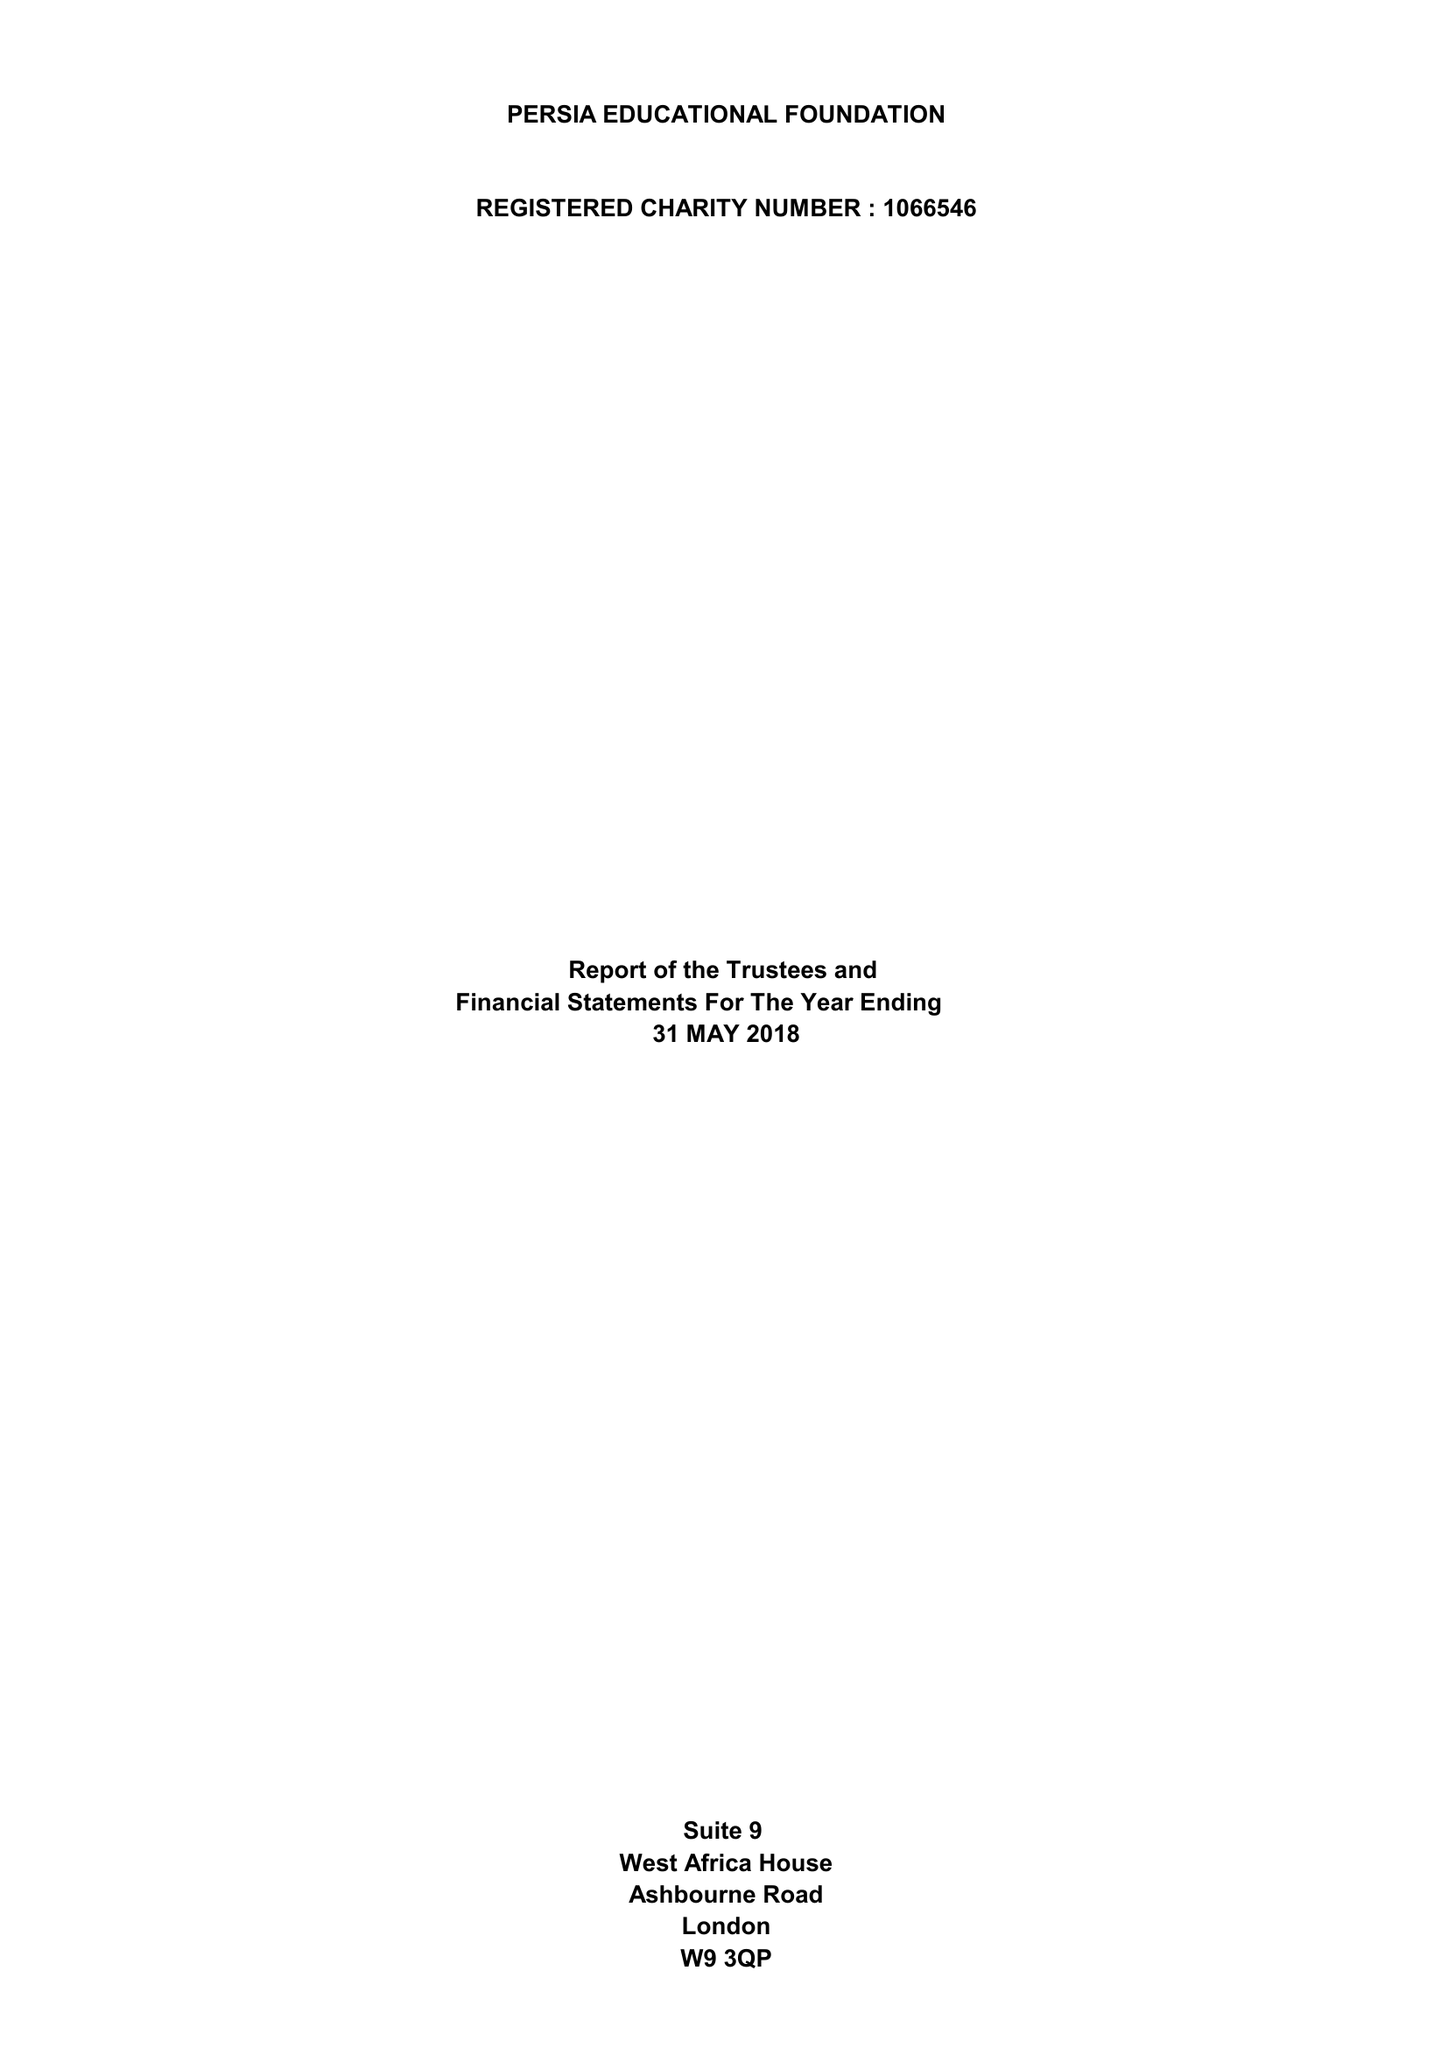What is the value for the address__post_town?
Answer the question using a single word or phrase. LONDON 